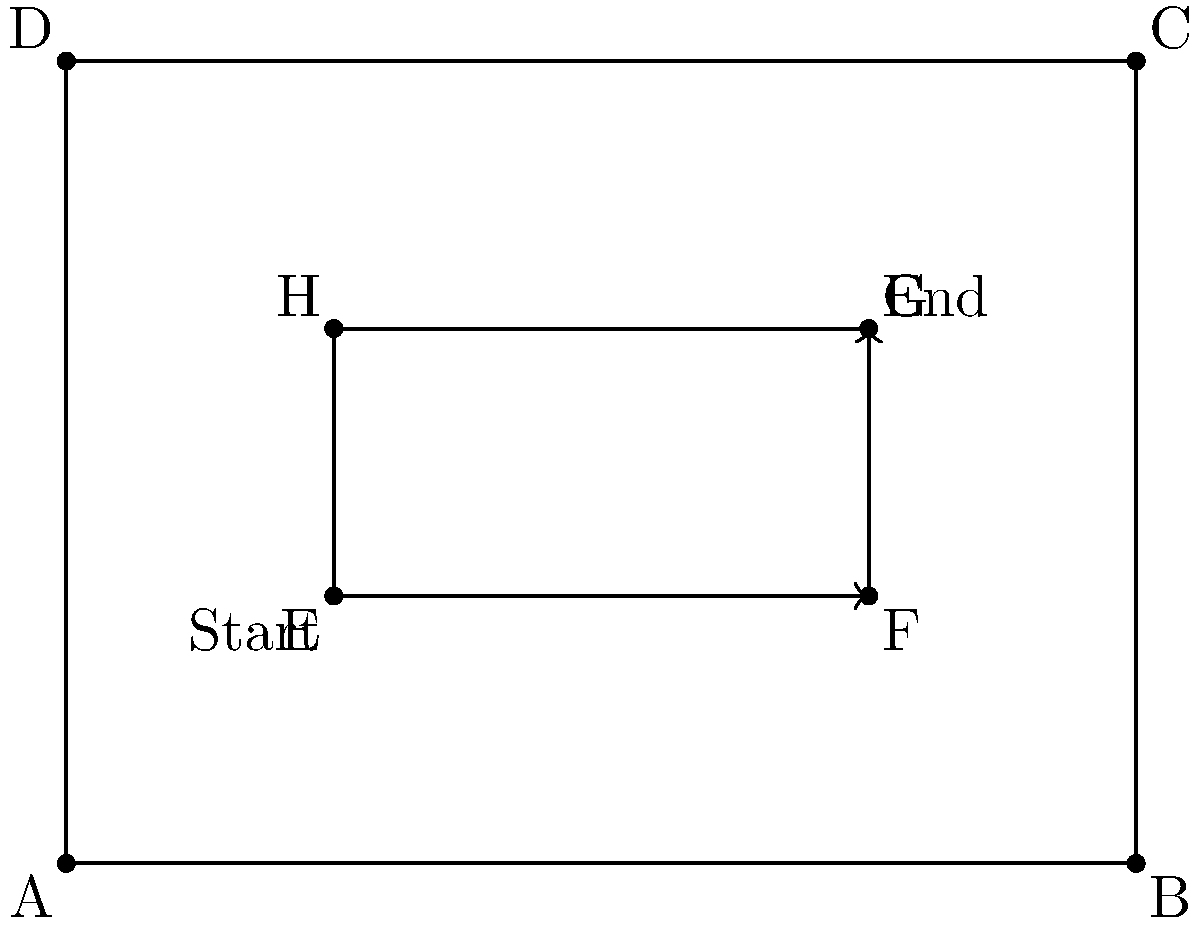In a factory setting, a robot needs to move from point E (Start) to point G (End) in the most efficient path. The robot can only move in straight lines parallel to the edges of the rectangle ABCD. Given that the rectangle ABCD has dimensions 8 units by 6 units, and EFGH is a smaller rectangle within ABCD, determine the sequence of transformations that would optimize the robot's movement path. Express your answer as a composition of transformations in the correct order. To optimize the robot's movement path from E to G, we need to break down the movement into two transformations:

1. Translation from E to F:
   The robot moves 4 units to the right along the x-axis.
   This can be represented as $T_{(4,0)}$.

2. Translation from F to G:
   The robot moves 2 units up along the y-axis.
   This can be represented as $T_{(0,2)}$.

To compose these transformations, we apply them in order from left to right. The resulting composition would be:

$T_{(0,2)} \circ T_{(4,0)}$

This composition represents first moving 4 units right, then 2 units up, which is the most efficient path for the robot to move from E to G given the constraints.
Answer: $T_{(0,2)} \circ T_{(4,0)}$ 